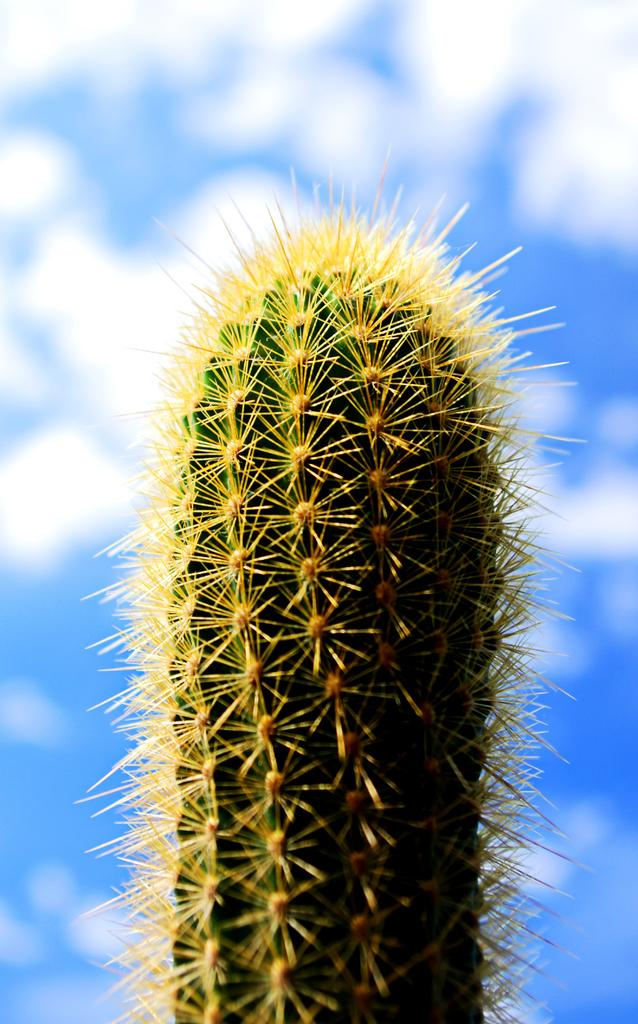What type of plant is in the picture? There is a cactus in the picture. Can you describe the background of the image? The background of the image is blurred. What type of jeans is the daughter wearing in the image? There is no daughter or jeans present in the image; it only features a cactus and a blurred background. 